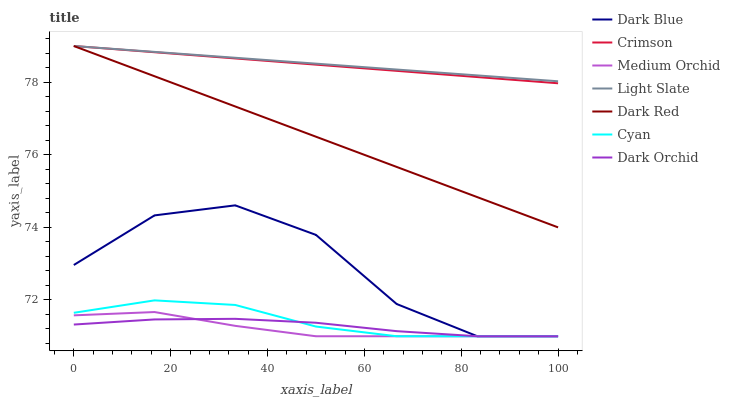Does Dark Red have the minimum area under the curve?
Answer yes or no. No. Does Dark Red have the maximum area under the curve?
Answer yes or no. No. Is Medium Orchid the smoothest?
Answer yes or no. No. Is Medium Orchid the roughest?
Answer yes or no. No. Does Dark Red have the lowest value?
Answer yes or no. No. Does Medium Orchid have the highest value?
Answer yes or no. No. Is Dark Blue less than Crimson?
Answer yes or no. Yes. Is Light Slate greater than Medium Orchid?
Answer yes or no. Yes. Does Dark Blue intersect Crimson?
Answer yes or no. No. 